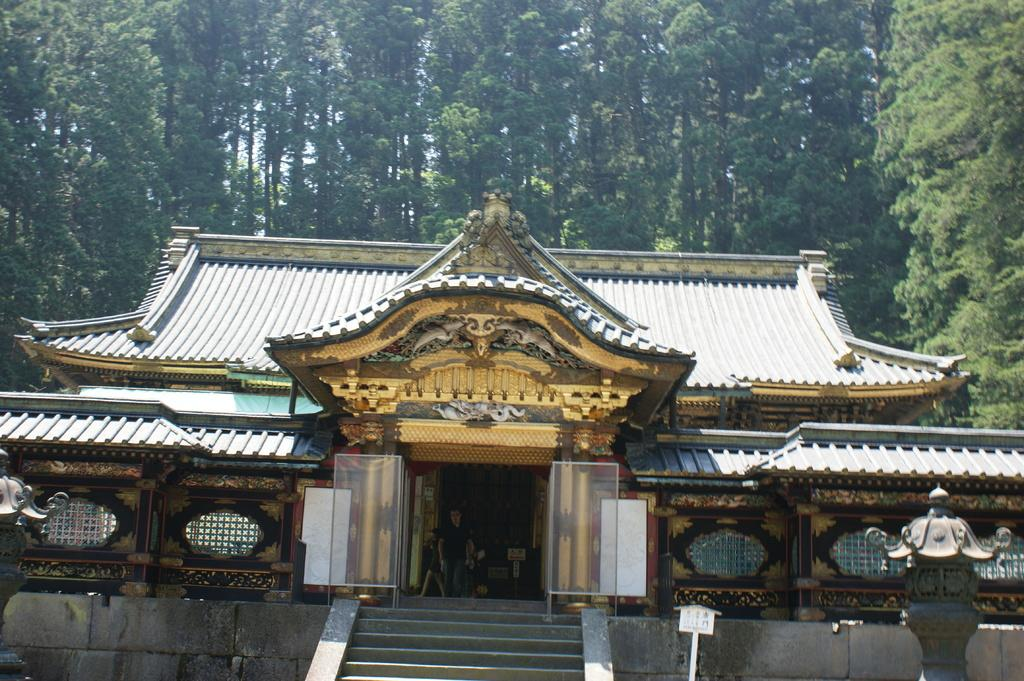How many people are walking in the image? There are three persons walking in the image. What can be seen in the background of the image? There is a brown-colored building and green-colored trees in the background. What is the color of the sky in the image? The sky appears to be white in color. What type of beast can be seen in the image? There is no beast present in the image. Where is the hall located in the image? There is no hall present in the image. 